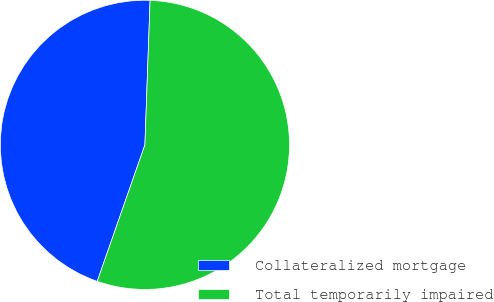<chart> <loc_0><loc_0><loc_500><loc_500><pie_chart><fcel>Collateralized mortgage<fcel>Total temporarily impaired<nl><fcel>45.22%<fcel>54.78%<nl></chart> 